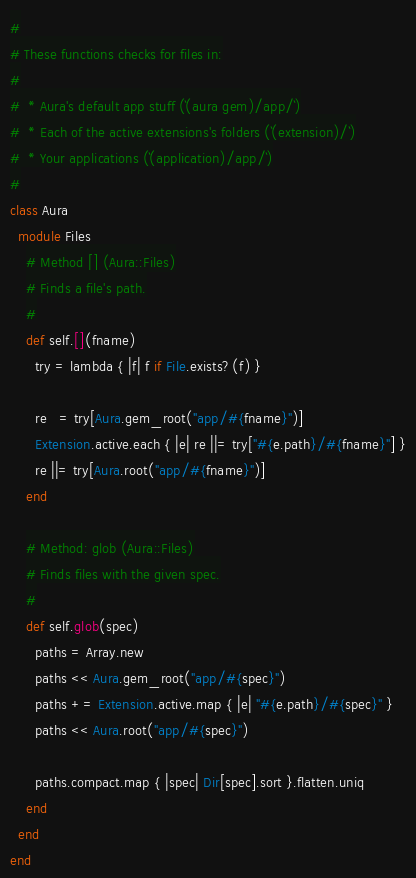<code> <loc_0><loc_0><loc_500><loc_500><_Ruby_>#
# These functions checks for files in:
#
#  * Aura's default app stuff (`(aura gem)/app/`)
#  * Each of the active extensions's folders (`(extension)/`)
#  * Your applications (`(application)/app/`)
#
class Aura
  module Files
    # Method [] (Aura::Files)
    # Finds a file's path.
    #
    def self.[](fname)
      try = lambda { |f| f if File.exists?(f) }

      re   = try[Aura.gem_root("app/#{fname}")]
      Extension.active.each { |e| re ||= try["#{e.path}/#{fname}"] }
      re ||= try[Aura.root("app/#{fname}")]
    end

    # Method: glob (Aura::Files)
    # Finds files with the given spec.
    #
    def self.glob(spec)
      paths = Array.new
      paths << Aura.gem_root("app/#{spec}")
      paths += Extension.active.map { |e| "#{e.path}/#{spec}" }
      paths << Aura.root("app/#{spec}")

      paths.compact.map { |spec| Dir[spec].sort }.flatten.uniq
    end
  end
end
</code> 